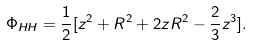<formula> <loc_0><loc_0><loc_500><loc_500>\Phi _ { H H } = \frac { 1 } { 2 } [ z ^ { 2 } + R ^ { 2 } + 2 z R ^ { 2 } - \frac { 2 } { 3 } z ^ { 3 } ] .</formula> 